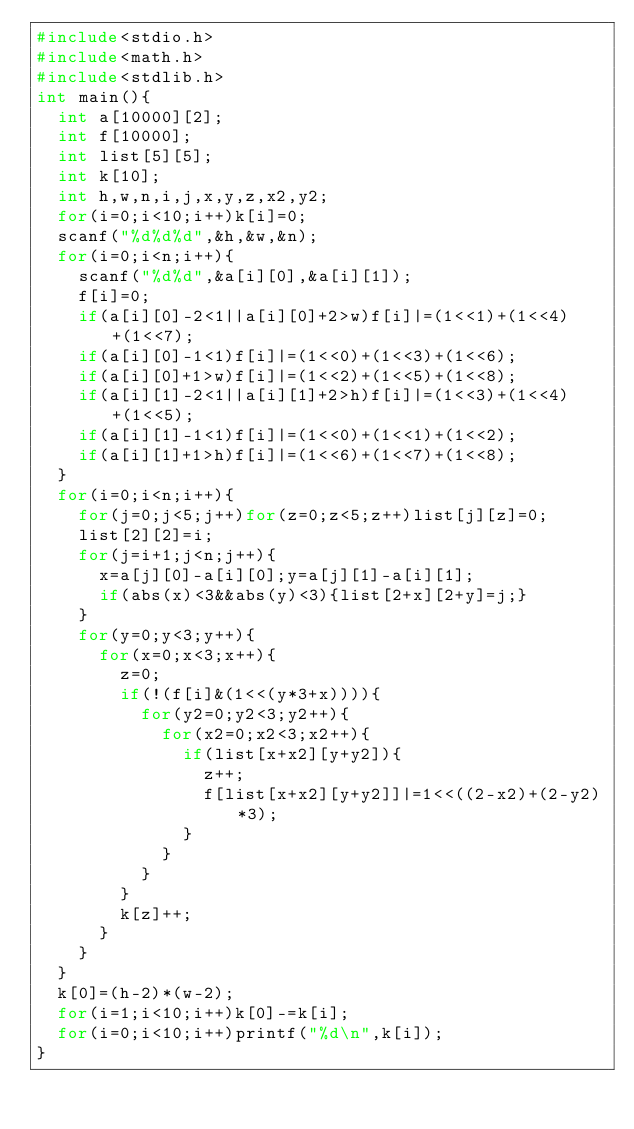<code> <loc_0><loc_0><loc_500><loc_500><_C_>#include<stdio.h>
#include<math.h>
#include<stdlib.h>
int main(){
  int a[10000][2];
  int f[10000];
  int list[5][5];
  int k[10];
  int h,w,n,i,j,x,y,z,x2,y2;
  for(i=0;i<10;i++)k[i]=0;
  scanf("%d%d%d",&h,&w,&n);
  for(i=0;i<n;i++){
    scanf("%d%d",&a[i][0],&a[i][1]);
    f[i]=0;
    if(a[i][0]-2<1||a[i][0]+2>w)f[i]|=(1<<1)+(1<<4)+(1<<7);
    if(a[i][0]-1<1)f[i]|=(1<<0)+(1<<3)+(1<<6);
    if(a[i][0]+1>w)f[i]|=(1<<2)+(1<<5)+(1<<8);
    if(a[i][1]-2<1||a[i][1]+2>h)f[i]|=(1<<3)+(1<<4)+(1<<5);
    if(a[i][1]-1<1)f[i]|=(1<<0)+(1<<1)+(1<<2);
    if(a[i][1]+1>h)f[i]|=(1<<6)+(1<<7)+(1<<8);
  }
  for(i=0;i<n;i++){
    for(j=0;j<5;j++)for(z=0;z<5;z++)list[j][z]=0;
    list[2][2]=i;
    for(j=i+1;j<n;j++){
      x=a[j][0]-a[i][0];y=a[j][1]-a[i][1];
      if(abs(x)<3&&abs(y)<3){list[2+x][2+y]=j;}
    }
    for(y=0;y<3;y++){
      for(x=0;x<3;x++){
        z=0;
        if(!(f[i]&(1<<(y*3+x)))){
          for(y2=0;y2<3;y2++){
            for(x2=0;x2<3;x2++){
              if(list[x+x2][y+y2]){
                z++;
                f[list[x+x2][y+y2]]|=1<<((2-x2)+(2-y2)*3);
              }
            }
          }
        }
        k[z]++;
      }
    }
  }
  k[0]=(h-2)*(w-2);
  for(i=1;i<10;i++)k[0]-=k[i];
  for(i=0;i<10;i++)printf("%d\n",k[i]);
}</code> 